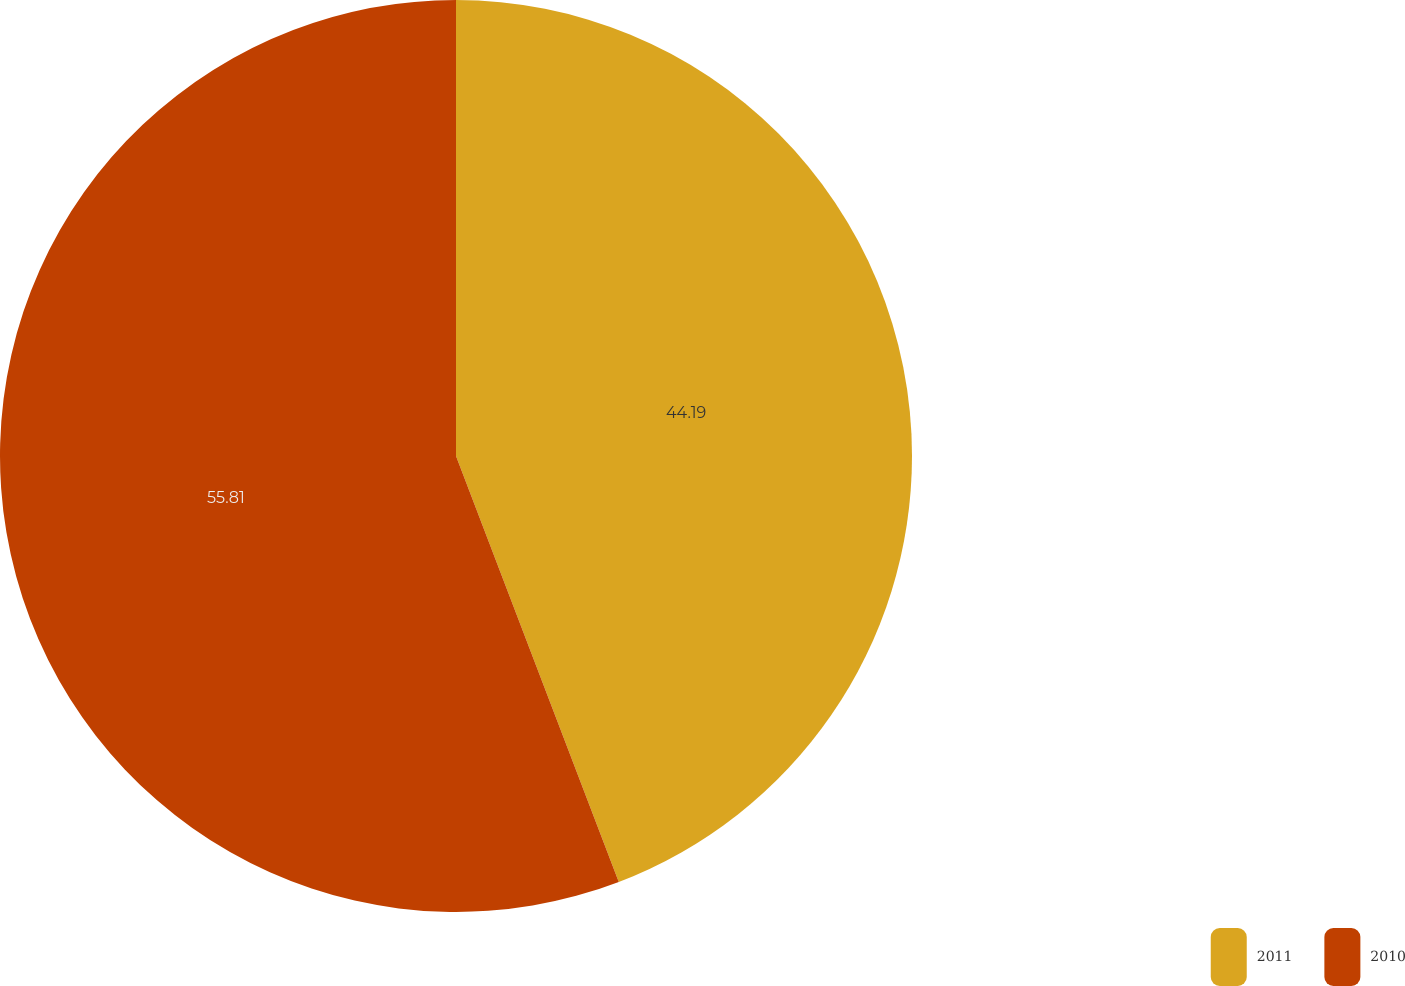<chart> <loc_0><loc_0><loc_500><loc_500><pie_chart><fcel>2011<fcel>2010<nl><fcel>44.19%<fcel>55.81%<nl></chart> 